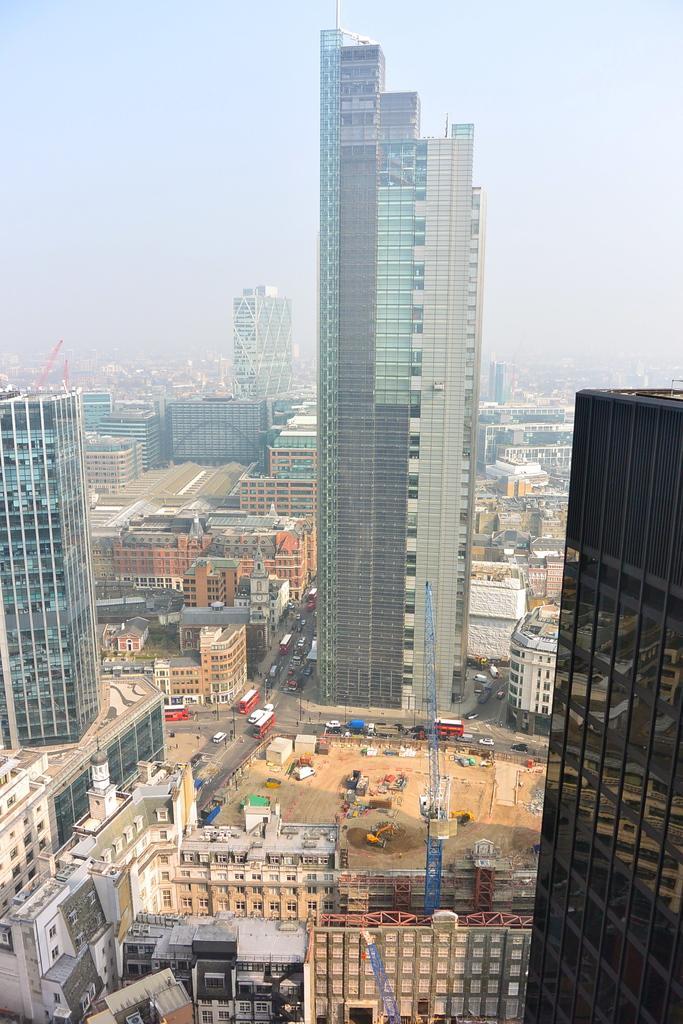Please provide a concise description of this image. In this image, we can see so many buildings, roads, vehicles, towers, houses. Background there is a sky. 